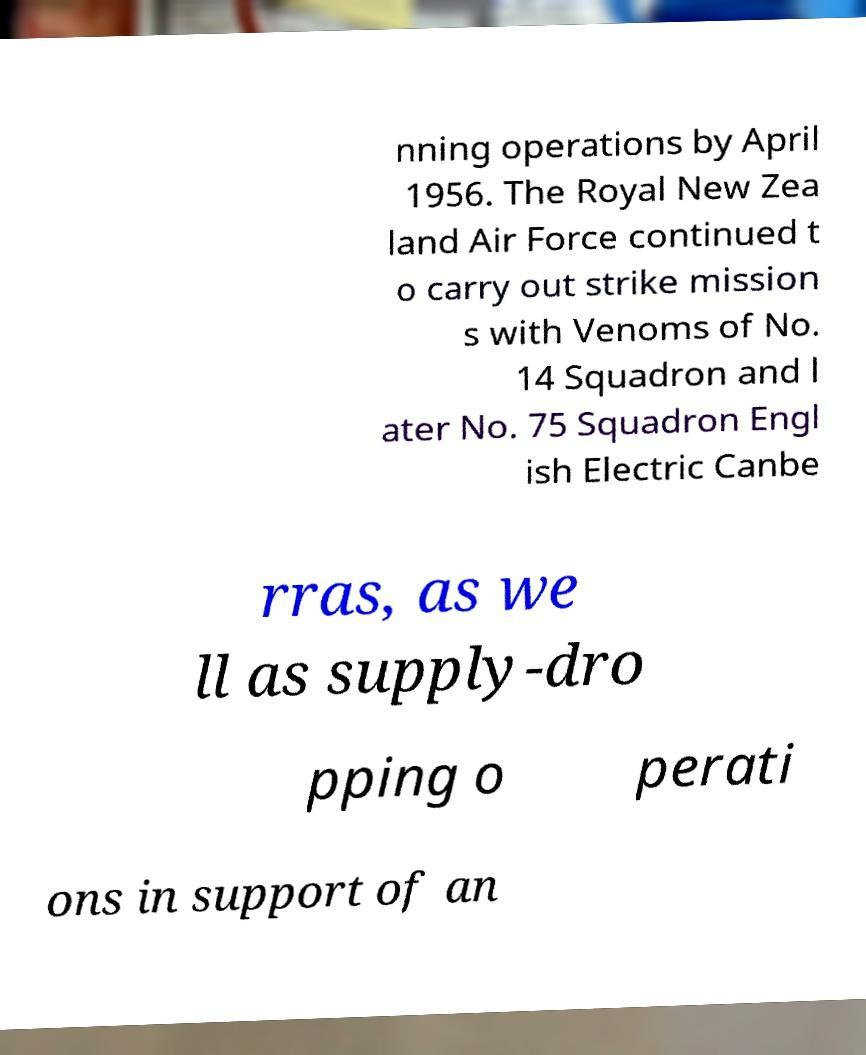Can you accurately transcribe the text from the provided image for me? nning operations by April 1956. The Royal New Zea land Air Force continued t o carry out strike mission s with Venoms of No. 14 Squadron and l ater No. 75 Squadron Engl ish Electric Canbe rras, as we ll as supply-dro pping o perati ons in support of an 